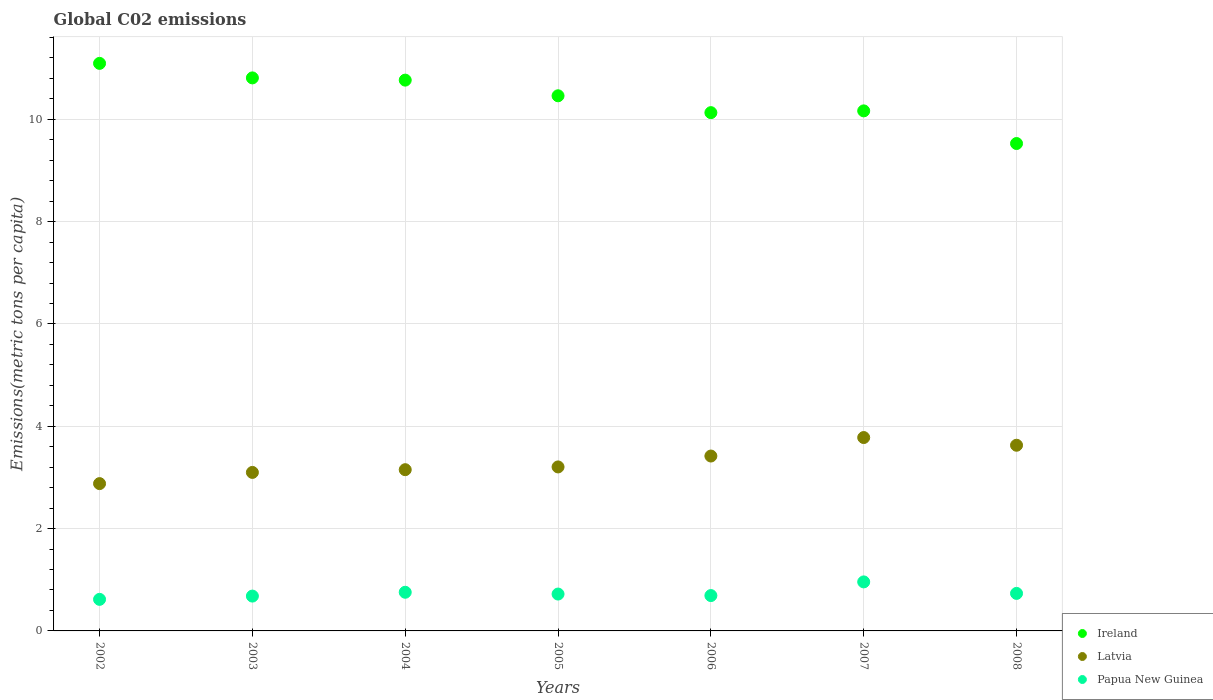How many different coloured dotlines are there?
Your answer should be compact. 3. What is the amount of CO2 emitted in in Ireland in 2002?
Your response must be concise. 11.09. Across all years, what is the maximum amount of CO2 emitted in in Papua New Guinea?
Keep it short and to the point. 0.96. Across all years, what is the minimum amount of CO2 emitted in in Papua New Guinea?
Your answer should be very brief. 0.62. What is the total amount of CO2 emitted in in Papua New Guinea in the graph?
Offer a terse response. 5.16. What is the difference between the amount of CO2 emitted in in Ireland in 2004 and that in 2008?
Keep it short and to the point. 1.24. What is the difference between the amount of CO2 emitted in in Papua New Guinea in 2003 and the amount of CO2 emitted in in Ireland in 2008?
Give a very brief answer. -8.85. What is the average amount of CO2 emitted in in Latvia per year?
Keep it short and to the point. 3.31. In the year 2006, what is the difference between the amount of CO2 emitted in in Latvia and amount of CO2 emitted in in Papua New Guinea?
Make the answer very short. 2.73. In how many years, is the amount of CO2 emitted in in Latvia greater than 10 metric tons per capita?
Keep it short and to the point. 0. What is the ratio of the amount of CO2 emitted in in Ireland in 2007 to that in 2008?
Give a very brief answer. 1.07. Is the amount of CO2 emitted in in Papua New Guinea in 2003 less than that in 2007?
Make the answer very short. Yes. What is the difference between the highest and the second highest amount of CO2 emitted in in Ireland?
Your answer should be compact. 0.28. What is the difference between the highest and the lowest amount of CO2 emitted in in Papua New Guinea?
Provide a succinct answer. 0.34. In how many years, is the amount of CO2 emitted in in Ireland greater than the average amount of CO2 emitted in in Ireland taken over all years?
Your answer should be compact. 4. Does the amount of CO2 emitted in in Latvia monotonically increase over the years?
Provide a succinct answer. No. Are the values on the major ticks of Y-axis written in scientific E-notation?
Keep it short and to the point. No. Does the graph contain any zero values?
Offer a terse response. No. Does the graph contain grids?
Your answer should be very brief. Yes. Where does the legend appear in the graph?
Your answer should be very brief. Bottom right. How many legend labels are there?
Make the answer very short. 3. What is the title of the graph?
Your answer should be very brief. Global C02 emissions. Does "Peru" appear as one of the legend labels in the graph?
Give a very brief answer. No. What is the label or title of the X-axis?
Your response must be concise. Years. What is the label or title of the Y-axis?
Offer a very short reply. Emissions(metric tons per capita). What is the Emissions(metric tons per capita) in Ireland in 2002?
Provide a succinct answer. 11.09. What is the Emissions(metric tons per capita) of Latvia in 2002?
Provide a succinct answer. 2.88. What is the Emissions(metric tons per capita) of Papua New Guinea in 2002?
Your answer should be very brief. 0.62. What is the Emissions(metric tons per capita) of Ireland in 2003?
Offer a terse response. 10.81. What is the Emissions(metric tons per capita) of Latvia in 2003?
Offer a terse response. 3.1. What is the Emissions(metric tons per capita) of Papua New Guinea in 2003?
Your answer should be very brief. 0.68. What is the Emissions(metric tons per capita) in Ireland in 2004?
Offer a very short reply. 10.77. What is the Emissions(metric tons per capita) of Latvia in 2004?
Provide a succinct answer. 3.15. What is the Emissions(metric tons per capita) of Papua New Guinea in 2004?
Offer a very short reply. 0.76. What is the Emissions(metric tons per capita) in Ireland in 2005?
Ensure brevity in your answer.  10.46. What is the Emissions(metric tons per capita) of Latvia in 2005?
Provide a short and direct response. 3.21. What is the Emissions(metric tons per capita) in Papua New Guinea in 2005?
Ensure brevity in your answer.  0.72. What is the Emissions(metric tons per capita) of Ireland in 2006?
Your response must be concise. 10.13. What is the Emissions(metric tons per capita) of Latvia in 2006?
Keep it short and to the point. 3.42. What is the Emissions(metric tons per capita) in Papua New Guinea in 2006?
Provide a short and direct response. 0.69. What is the Emissions(metric tons per capita) of Ireland in 2007?
Your answer should be very brief. 10.17. What is the Emissions(metric tons per capita) of Latvia in 2007?
Your response must be concise. 3.78. What is the Emissions(metric tons per capita) in Papua New Guinea in 2007?
Keep it short and to the point. 0.96. What is the Emissions(metric tons per capita) of Ireland in 2008?
Offer a very short reply. 9.53. What is the Emissions(metric tons per capita) of Latvia in 2008?
Make the answer very short. 3.63. What is the Emissions(metric tons per capita) of Papua New Guinea in 2008?
Offer a very short reply. 0.73. Across all years, what is the maximum Emissions(metric tons per capita) in Ireland?
Offer a very short reply. 11.09. Across all years, what is the maximum Emissions(metric tons per capita) in Latvia?
Offer a very short reply. 3.78. Across all years, what is the maximum Emissions(metric tons per capita) in Papua New Guinea?
Ensure brevity in your answer.  0.96. Across all years, what is the minimum Emissions(metric tons per capita) in Ireland?
Provide a succinct answer. 9.53. Across all years, what is the minimum Emissions(metric tons per capita) of Latvia?
Offer a very short reply. 2.88. Across all years, what is the minimum Emissions(metric tons per capita) in Papua New Guinea?
Give a very brief answer. 0.62. What is the total Emissions(metric tons per capita) of Ireland in the graph?
Offer a terse response. 72.95. What is the total Emissions(metric tons per capita) of Latvia in the graph?
Your response must be concise. 23.16. What is the total Emissions(metric tons per capita) of Papua New Guinea in the graph?
Keep it short and to the point. 5.16. What is the difference between the Emissions(metric tons per capita) in Ireland in 2002 and that in 2003?
Offer a very short reply. 0.28. What is the difference between the Emissions(metric tons per capita) of Latvia in 2002 and that in 2003?
Your answer should be compact. -0.22. What is the difference between the Emissions(metric tons per capita) in Papua New Guinea in 2002 and that in 2003?
Keep it short and to the point. -0.06. What is the difference between the Emissions(metric tons per capita) in Ireland in 2002 and that in 2004?
Offer a terse response. 0.33. What is the difference between the Emissions(metric tons per capita) in Latvia in 2002 and that in 2004?
Keep it short and to the point. -0.27. What is the difference between the Emissions(metric tons per capita) of Papua New Guinea in 2002 and that in 2004?
Give a very brief answer. -0.14. What is the difference between the Emissions(metric tons per capita) of Ireland in 2002 and that in 2005?
Give a very brief answer. 0.63. What is the difference between the Emissions(metric tons per capita) of Latvia in 2002 and that in 2005?
Provide a succinct answer. -0.33. What is the difference between the Emissions(metric tons per capita) in Papua New Guinea in 2002 and that in 2005?
Provide a short and direct response. -0.1. What is the difference between the Emissions(metric tons per capita) in Ireland in 2002 and that in 2006?
Give a very brief answer. 0.96. What is the difference between the Emissions(metric tons per capita) in Latvia in 2002 and that in 2006?
Ensure brevity in your answer.  -0.54. What is the difference between the Emissions(metric tons per capita) of Papua New Guinea in 2002 and that in 2006?
Your answer should be compact. -0.07. What is the difference between the Emissions(metric tons per capita) of Ireland in 2002 and that in 2007?
Give a very brief answer. 0.93. What is the difference between the Emissions(metric tons per capita) in Latvia in 2002 and that in 2007?
Provide a succinct answer. -0.9. What is the difference between the Emissions(metric tons per capita) in Papua New Guinea in 2002 and that in 2007?
Ensure brevity in your answer.  -0.34. What is the difference between the Emissions(metric tons per capita) in Ireland in 2002 and that in 2008?
Your answer should be very brief. 1.57. What is the difference between the Emissions(metric tons per capita) of Latvia in 2002 and that in 2008?
Make the answer very short. -0.75. What is the difference between the Emissions(metric tons per capita) in Papua New Guinea in 2002 and that in 2008?
Your answer should be very brief. -0.12. What is the difference between the Emissions(metric tons per capita) of Ireland in 2003 and that in 2004?
Ensure brevity in your answer.  0.04. What is the difference between the Emissions(metric tons per capita) in Latvia in 2003 and that in 2004?
Provide a short and direct response. -0.05. What is the difference between the Emissions(metric tons per capita) in Papua New Guinea in 2003 and that in 2004?
Your answer should be compact. -0.07. What is the difference between the Emissions(metric tons per capita) in Ireland in 2003 and that in 2005?
Offer a very short reply. 0.35. What is the difference between the Emissions(metric tons per capita) of Latvia in 2003 and that in 2005?
Offer a terse response. -0.11. What is the difference between the Emissions(metric tons per capita) in Papua New Guinea in 2003 and that in 2005?
Your response must be concise. -0.04. What is the difference between the Emissions(metric tons per capita) of Ireland in 2003 and that in 2006?
Your answer should be compact. 0.68. What is the difference between the Emissions(metric tons per capita) of Latvia in 2003 and that in 2006?
Offer a very short reply. -0.32. What is the difference between the Emissions(metric tons per capita) in Papua New Guinea in 2003 and that in 2006?
Give a very brief answer. -0.01. What is the difference between the Emissions(metric tons per capita) in Ireland in 2003 and that in 2007?
Make the answer very short. 0.64. What is the difference between the Emissions(metric tons per capita) in Latvia in 2003 and that in 2007?
Make the answer very short. -0.68. What is the difference between the Emissions(metric tons per capita) in Papua New Guinea in 2003 and that in 2007?
Provide a short and direct response. -0.28. What is the difference between the Emissions(metric tons per capita) in Ireland in 2003 and that in 2008?
Ensure brevity in your answer.  1.28. What is the difference between the Emissions(metric tons per capita) in Latvia in 2003 and that in 2008?
Provide a succinct answer. -0.53. What is the difference between the Emissions(metric tons per capita) in Papua New Guinea in 2003 and that in 2008?
Give a very brief answer. -0.05. What is the difference between the Emissions(metric tons per capita) in Ireland in 2004 and that in 2005?
Your response must be concise. 0.31. What is the difference between the Emissions(metric tons per capita) in Latvia in 2004 and that in 2005?
Make the answer very short. -0.05. What is the difference between the Emissions(metric tons per capita) of Papua New Guinea in 2004 and that in 2005?
Keep it short and to the point. 0.04. What is the difference between the Emissions(metric tons per capita) in Ireland in 2004 and that in 2006?
Ensure brevity in your answer.  0.64. What is the difference between the Emissions(metric tons per capita) in Latvia in 2004 and that in 2006?
Your answer should be very brief. -0.27. What is the difference between the Emissions(metric tons per capita) of Papua New Guinea in 2004 and that in 2006?
Keep it short and to the point. 0.06. What is the difference between the Emissions(metric tons per capita) in Ireland in 2004 and that in 2007?
Offer a very short reply. 0.6. What is the difference between the Emissions(metric tons per capita) in Latvia in 2004 and that in 2007?
Your response must be concise. -0.63. What is the difference between the Emissions(metric tons per capita) of Papua New Guinea in 2004 and that in 2007?
Offer a very short reply. -0.2. What is the difference between the Emissions(metric tons per capita) in Ireland in 2004 and that in 2008?
Provide a succinct answer. 1.24. What is the difference between the Emissions(metric tons per capita) in Latvia in 2004 and that in 2008?
Ensure brevity in your answer.  -0.48. What is the difference between the Emissions(metric tons per capita) in Papua New Guinea in 2004 and that in 2008?
Provide a short and direct response. 0.02. What is the difference between the Emissions(metric tons per capita) in Ireland in 2005 and that in 2006?
Your response must be concise. 0.33. What is the difference between the Emissions(metric tons per capita) of Latvia in 2005 and that in 2006?
Give a very brief answer. -0.21. What is the difference between the Emissions(metric tons per capita) in Papua New Guinea in 2005 and that in 2006?
Provide a succinct answer. 0.03. What is the difference between the Emissions(metric tons per capita) in Ireland in 2005 and that in 2007?
Provide a short and direct response. 0.29. What is the difference between the Emissions(metric tons per capita) of Latvia in 2005 and that in 2007?
Provide a short and direct response. -0.57. What is the difference between the Emissions(metric tons per capita) in Papua New Guinea in 2005 and that in 2007?
Your response must be concise. -0.24. What is the difference between the Emissions(metric tons per capita) of Ireland in 2005 and that in 2008?
Keep it short and to the point. 0.93. What is the difference between the Emissions(metric tons per capita) in Latvia in 2005 and that in 2008?
Offer a very short reply. -0.42. What is the difference between the Emissions(metric tons per capita) of Papua New Guinea in 2005 and that in 2008?
Your answer should be very brief. -0.01. What is the difference between the Emissions(metric tons per capita) in Ireland in 2006 and that in 2007?
Offer a very short reply. -0.03. What is the difference between the Emissions(metric tons per capita) in Latvia in 2006 and that in 2007?
Ensure brevity in your answer.  -0.36. What is the difference between the Emissions(metric tons per capita) in Papua New Guinea in 2006 and that in 2007?
Ensure brevity in your answer.  -0.27. What is the difference between the Emissions(metric tons per capita) of Ireland in 2006 and that in 2008?
Provide a short and direct response. 0.6. What is the difference between the Emissions(metric tons per capita) of Latvia in 2006 and that in 2008?
Ensure brevity in your answer.  -0.21. What is the difference between the Emissions(metric tons per capita) of Papua New Guinea in 2006 and that in 2008?
Offer a terse response. -0.04. What is the difference between the Emissions(metric tons per capita) in Ireland in 2007 and that in 2008?
Your answer should be very brief. 0.64. What is the difference between the Emissions(metric tons per capita) of Latvia in 2007 and that in 2008?
Provide a short and direct response. 0.15. What is the difference between the Emissions(metric tons per capita) in Papua New Guinea in 2007 and that in 2008?
Provide a succinct answer. 0.22. What is the difference between the Emissions(metric tons per capita) in Ireland in 2002 and the Emissions(metric tons per capita) in Latvia in 2003?
Your answer should be compact. 8. What is the difference between the Emissions(metric tons per capita) of Ireland in 2002 and the Emissions(metric tons per capita) of Papua New Guinea in 2003?
Your answer should be compact. 10.41. What is the difference between the Emissions(metric tons per capita) in Latvia in 2002 and the Emissions(metric tons per capita) in Papua New Guinea in 2003?
Give a very brief answer. 2.2. What is the difference between the Emissions(metric tons per capita) of Ireland in 2002 and the Emissions(metric tons per capita) of Latvia in 2004?
Your answer should be very brief. 7.94. What is the difference between the Emissions(metric tons per capita) in Ireland in 2002 and the Emissions(metric tons per capita) in Papua New Guinea in 2004?
Ensure brevity in your answer.  10.34. What is the difference between the Emissions(metric tons per capita) of Latvia in 2002 and the Emissions(metric tons per capita) of Papua New Guinea in 2004?
Your response must be concise. 2.12. What is the difference between the Emissions(metric tons per capita) of Ireland in 2002 and the Emissions(metric tons per capita) of Latvia in 2005?
Give a very brief answer. 7.89. What is the difference between the Emissions(metric tons per capita) of Ireland in 2002 and the Emissions(metric tons per capita) of Papua New Guinea in 2005?
Keep it short and to the point. 10.37. What is the difference between the Emissions(metric tons per capita) in Latvia in 2002 and the Emissions(metric tons per capita) in Papua New Guinea in 2005?
Your answer should be very brief. 2.16. What is the difference between the Emissions(metric tons per capita) in Ireland in 2002 and the Emissions(metric tons per capita) in Latvia in 2006?
Make the answer very short. 7.67. What is the difference between the Emissions(metric tons per capita) in Ireland in 2002 and the Emissions(metric tons per capita) in Papua New Guinea in 2006?
Provide a succinct answer. 10.4. What is the difference between the Emissions(metric tons per capita) of Latvia in 2002 and the Emissions(metric tons per capita) of Papua New Guinea in 2006?
Provide a succinct answer. 2.19. What is the difference between the Emissions(metric tons per capita) in Ireland in 2002 and the Emissions(metric tons per capita) in Latvia in 2007?
Keep it short and to the point. 7.31. What is the difference between the Emissions(metric tons per capita) in Ireland in 2002 and the Emissions(metric tons per capita) in Papua New Guinea in 2007?
Give a very brief answer. 10.14. What is the difference between the Emissions(metric tons per capita) of Latvia in 2002 and the Emissions(metric tons per capita) of Papua New Guinea in 2007?
Offer a very short reply. 1.92. What is the difference between the Emissions(metric tons per capita) in Ireland in 2002 and the Emissions(metric tons per capita) in Latvia in 2008?
Ensure brevity in your answer.  7.46. What is the difference between the Emissions(metric tons per capita) of Ireland in 2002 and the Emissions(metric tons per capita) of Papua New Guinea in 2008?
Provide a short and direct response. 10.36. What is the difference between the Emissions(metric tons per capita) in Latvia in 2002 and the Emissions(metric tons per capita) in Papua New Guinea in 2008?
Provide a succinct answer. 2.15. What is the difference between the Emissions(metric tons per capita) of Ireland in 2003 and the Emissions(metric tons per capita) of Latvia in 2004?
Provide a short and direct response. 7.66. What is the difference between the Emissions(metric tons per capita) in Ireland in 2003 and the Emissions(metric tons per capita) in Papua New Guinea in 2004?
Your answer should be very brief. 10.05. What is the difference between the Emissions(metric tons per capita) in Latvia in 2003 and the Emissions(metric tons per capita) in Papua New Guinea in 2004?
Your answer should be compact. 2.34. What is the difference between the Emissions(metric tons per capita) of Ireland in 2003 and the Emissions(metric tons per capita) of Latvia in 2005?
Provide a succinct answer. 7.6. What is the difference between the Emissions(metric tons per capita) of Ireland in 2003 and the Emissions(metric tons per capita) of Papua New Guinea in 2005?
Make the answer very short. 10.09. What is the difference between the Emissions(metric tons per capita) of Latvia in 2003 and the Emissions(metric tons per capita) of Papua New Guinea in 2005?
Your answer should be very brief. 2.38. What is the difference between the Emissions(metric tons per capita) in Ireland in 2003 and the Emissions(metric tons per capita) in Latvia in 2006?
Ensure brevity in your answer.  7.39. What is the difference between the Emissions(metric tons per capita) in Ireland in 2003 and the Emissions(metric tons per capita) in Papua New Guinea in 2006?
Give a very brief answer. 10.12. What is the difference between the Emissions(metric tons per capita) in Latvia in 2003 and the Emissions(metric tons per capita) in Papua New Guinea in 2006?
Give a very brief answer. 2.41. What is the difference between the Emissions(metric tons per capita) in Ireland in 2003 and the Emissions(metric tons per capita) in Latvia in 2007?
Your answer should be very brief. 7.03. What is the difference between the Emissions(metric tons per capita) of Ireland in 2003 and the Emissions(metric tons per capita) of Papua New Guinea in 2007?
Give a very brief answer. 9.85. What is the difference between the Emissions(metric tons per capita) in Latvia in 2003 and the Emissions(metric tons per capita) in Papua New Guinea in 2007?
Provide a short and direct response. 2.14. What is the difference between the Emissions(metric tons per capita) in Ireland in 2003 and the Emissions(metric tons per capita) in Latvia in 2008?
Ensure brevity in your answer.  7.18. What is the difference between the Emissions(metric tons per capita) in Ireland in 2003 and the Emissions(metric tons per capita) in Papua New Guinea in 2008?
Your response must be concise. 10.08. What is the difference between the Emissions(metric tons per capita) of Latvia in 2003 and the Emissions(metric tons per capita) of Papua New Guinea in 2008?
Provide a succinct answer. 2.36. What is the difference between the Emissions(metric tons per capita) in Ireland in 2004 and the Emissions(metric tons per capita) in Latvia in 2005?
Your answer should be compact. 7.56. What is the difference between the Emissions(metric tons per capita) of Ireland in 2004 and the Emissions(metric tons per capita) of Papua New Guinea in 2005?
Ensure brevity in your answer.  10.05. What is the difference between the Emissions(metric tons per capita) of Latvia in 2004 and the Emissions(metric tons per capita) of Papua New Guinea in 2005?
Make the answer very short. 2.43. What is the difference between the Emissions(metric tons per capita) of Ireland in 2004 and the Emissions(metric tons per capita) of Latvia in 2006?
Your answer should be very brief. 7.35. What is the difference between the Emissions(metric tons per capita) in Ireland in 2004 and the Emissions(metric tons per capita) in Papua New Guinea in 2006?
Provide a succinct answer. 10.08. What is the difference between the Emissions(metric tons per capita) in Latvia in 2004 and the Emissions(metric tons per capita) in Papua New Guinea in 2006?
Make the answer very short. 2.46. What is the difference between the Emissions(metric tons per capita) of Ireland in 2004 and the Emissions(metric tons per capita) of Latvia in 2007?
Your response must be concise. 6.99. What is the difference between the Emissions(metric tons per capita) in Ireland in 2004 and the Emissions(metric tons per capita) in Papua New Guinea in 2007?
Offer a terse response. 9.81. What is the difference between the Emissions(metric tons per capita) in Latvia in 2004 and the Emissions(metric tons per capita) in Papua New Guinea in 2007?
Ensure brevity in your answer.  2.19. What is the difference between the Emissions(metric tons per capita) in Ireland in 2004 and the Emissions(metric tons per capita) in Latvia in 2008?
Make the answer very short. 7.14. What is the difference between the Emissions(metric tons per capita) of Ireland in 2004 and the Emissions(metric tons per capita) of Papua New Guinea in 2008?
Offer a terse response. 10.03. What is the difference between the Emissions(metric tons per capita) of Latvia in 2004 and the Emissions(metric tons per capita) of Papua New Guinea in 2008?
Ensure brevity in your answer.  2.42. What is the difference between the Emissions(metric tons per capita) of Ireland in 2005 and the Emissions(metric tons per capita) of Latvia in 2006?
Provide a short and direct response. 7.04. What is the difference between the Emissions(metric tons per capita) in Ireland in 2005 and the Emissions(metric tons per capita) in Papua New Guinea in 2006?
Make the answer very short. 9.77. What is the difference between the Emissions(metric tons per capita) of Latvia in 2005 and the Emissions(metric tons per capita) of Papua New Guinea in 2006?
Provide a succinct answer. 2.51. What is the difference between the Emissions(metric tons per capita) of Ireland in 2005 and the Emissions(metric tons per capita) of Latvia in 2007?
Give a very brief answer. 6.68. What is the difference between the Emissions(metric tons per capita) in Ireland in 2005 and the Emissions(metric tons per capita) in Papua New Guinea in 2007?
Give a very brief answer. 9.5. What is the difference between the Emissions(metric tons per capita) of Latvia in 2005 and the Emissions(metric tons per capita) of Papua New Guinea in 2007?
Ensure brevity in your answer.  2.25. What is the difference between the Emissions(metric tons per capita) in Ireland in 2005 and the Emissions(metric tons per capita) in Latvia in 2008?
Give a very brief answer. 6.83. What is the difference between the Emissions(metric tons per capita) in Ireland in 2005 and the Emissions(metric tons per capita) in Papua New Guinea in 2008?
Keep it short and to the point. 9.73. What is the difference between the Emissions(metric tons per capita) in Latvia in 2005 and the Emissions(metric tons per capita) in Papua New Guinea in 2008?
Ensure brevity in your answer.  2.47. What is the difference between the Emissions(metric tons per capita) of Ireland in 2006 and the Emissions(metric tons per capita) of Latvia in 2007?
Ensure brevity in your answer.  6.35. What is the difference between the Emissions(metric tons per capita) in Ireland in 2006 and the Emissions(metric tons per capita) in Papua New Guinea in 2007?
Your answer should be compact. 9.17. What is the difference between the Emissions(metric tons per capita) of Latvia in 2006 and the Emissions(metric tons per capita) of Papua New Guinea in 2007?
Keep it short and to the point. 2.46. What is the difference between the Emissions(metric tons per capita) in Ireland in 2006 and the Emissions(metric tons per capita) in Latvia in 2008?
Offer a terse response. 6.5. What is the difference between the Emissions(metric tons per capita) of Ireland in 2006 and the Emissions(metric tons per capita) of Papua New Guinea in 2008?
Your response must be concise. 9.4. What is the difference between the Emissions(metric tons per capita) of Latvia in 2006 and the Emissions(metric tons per capita) of Papua New Guinea in 2008?
Ensure brevity in your answer.  2.69. What is the difference between the Emissions(metric tons per capita) in Ireland in 2007 and the Emissions(metric tons per capita) in Latvia in 2008?
Keep it short and to the point. 6.54. What is the difference between the Emissions(metric tons per capita) in Ireland in 2007 and the Emissions(metric tons per capita) in Papua New Guinea in 2008?
Give a very brief answer. 9.43. What is the difference between the Emissions(metric tons per capita) in Latvia in 2007 and the Emissions(metric tons per capita) in Papua New Guinea in 2008?
Give a very brief answer. 3.05. What is the average Emissions(metric tons per capita) in Ireland per year?
Offer a very short reply. 10.42. What is the average Emissions(metric tons per capita) of Latvia per year?
Offer a terse response. 3.31. What is the average Emissions(metric tons per capita) of Papua New Guinea per year?
Offer a terse response. 0.74. In the year 2002, what is the difference between the Emissions(metric tons per capita) in Ireland and Emissions(metric tons per capita) in Latvia?
Make the answer very short. 8.21. In the year 2002, what is the difference between the Emissions(metric tons per capita) of Ireland and Emissions(metric tons per capita) of Papua New Guinea?
Provide a succinct answer. 10.48. In the year 2002, what is the difference between the Emissions(metric tons per capita) in Latvia and Emissions(metric tons per capita) in Papua New Guinea?
Your response must be concise. 2.26. In the year 2003, what is the difference between the Emissions(metric tons per capita) in Ireland and Emissions(metric tons per capita) in Latvia?
Give a very brief answer. 7.71. In the year 2003, what is the difference between the Emissions(metric tons per capita) of Ireland and Emissions(metric tons per capita) of Papua New Guinea?
Offer a terse response. 10.13. In the year 2003, what is the difference between the Emissions(metric tons per capita) in Latvia and Emissions(metric tons per capita) in Papua New Guinea?
Make the answer very short. 2.42. In the year 2004, what is the difference between the Emissions(metric tons per capita) of Ireland and Emissions(metric tons per capita) of Latvia?
Your response must be concise. 7.61. In the year 2004, what is the difference between the Emissions(metric tons per capita) in Ireland and Emissions(metric tons per capita) in Papua New Guinea?
Make the answer very short. 10.01. In the year 2004, what is the difference between the Emissions(metric tons per capita) of Latvia and Emissions(metric tons per capita) of Papua New Guinea?
Ensure brevity in your answer.  2.4. In the year 2005, what is the difference between the Emissions(metric tons per capita) of Ireland and Emissions(metric tons per capita) of Latvia?
Provide a short and direct response. 7.25. In the year 2005, what is the difference between the Emissions(metric tons per capita) in Ireland and Emissions(metric tons per capita) in Papua New Guinea?
Your answer should be very brief. 9.74. In the year 2005, what is the difference between the Emissions(metric tons per capita) of Latvia and Emissions(metric tons per capita) of Papua New Guinea?
Ensure brevity in your answer.  2.48. In the year 2006, what is the difference between the Emissions(metric tons per capita) in Ireland and Emissions(metric tons per capita) in Latvia?
Give a very brief answer. 6.71. In the year 2006, what is the difference between the Emissions(metric tons per capita) of Ireland and Emissions(metric tons per capita) of Papua New Guinea?
Ensure brevity in your answer.  9.44. In the year 2006, what is the difference between the Emissions(metric tons per capita) in Latvia and Emissions(metric tons per capita) in Papua New Guinea?
Keep it short and to the point. 2.73. In the year 2007, what is the difference between the Emissions(metric tons per capita) in Ireland and Emissions(metric tons per capita) in Latvia?
Your answer should be very brief. 6.39. In the year 2007, what is the difference between the Emissions(metric tons per capita) of Ireland and Emissions(metric tons per capita) of Papua New Guinea?
Your response must be concise. 9.21. In the year 2007, what is the difference between the Emissions(metric tons per capita) of Latvia and Emissions(metric tons per capita) of Papua New Guinea?
Give a very brief answer. 2.82. In the year 2008, what is the difference between the Emissions(metric tons per capita) of Ireland and Emissions(metric tons per capita) of Latvia?
Your answer should be compact. 5.9. In the year 2008, what is the difference between the Emissions(metric tons per capita) of Ireland and Emissions(metric tons per capita) of Papua New Guinea?
Make the answer very short. 8.79. In the year 2008, what is the difference between the Emissions(metric tons per capita) of Latvia and Emissions(metric tons per capita) of Papua New Guinea?
Keep it short and to the point. 2.9. What is the ratio of the Emissions(metric tons per capita) of Ireland in 2002 to that in 2003?
Your answer should be compact. 1.03. What is the ratio of the Emissions(metric tons per capita) in Latvia in 2002 to that in 2003?
Ensure brevity in your answer.  0.93. What is the ratio of the Emissions(metric tons per capita) of Papua New Guinea in 2002 to that in 2003?
Offer a very short reply. 0.91. What is the ratio of the Emissions(metric tons per capita) in Ireland in 2002 to that in 2004?
Offer a terse response. 1.03. What is the ratio of the Emissions(metric tons per capita) in Latvia in 2002 to that in 2004?
Ensure brevity in your answer.  0.91. What is the ratio of the Emissions(metric tons per capita) in Papua New Guinea in 2002 to that in 2004?
Give a very brief answer. 0.82. What is the ratio of the Emissions(metric tons per capita) in Ireland in 2002 to that in 2005?
Provide a succinct answer. 1.06. What is the ratio of the Emissions(metric tons per capita) in Latvia in 2002 to that in 2005?
Give a very brief answer. 0.9. What is the ratio of the Emissions(metric tons per capita) of Papua New Guinea in 2002 to that in 2005?
Give a very brief answer. 0.86. What is the ratio of the Emissions(metric tons per capita) of Ireland in 2002 to that in 2006?
Ensure brevity in your answer.  1.1. What is the ratio of the Emissions(metric tons per capita) of Latvia in 2002 to that in 2006?
Give a very brief answer. 0.84. What is the ratio of the Emissions(metric tons per capita) of Papua New Guinea in 2002 to that in 2006?
Ensure brevity in your answer.  0.89. What is the ratio of the Emissions(metric tons per capita) in Ireland in 2002 to that in 2007?
Ensure brevity in your answer.  1.09. What is the ratio of the Emissions(metric tons per capita) in Latvia in 2002 to that in 2007?
Your answer should be compact. 0.76. What is the ratio of the Emissions(metric tons per capita) of Papua New Guinea in 2002 to that in 2007?
Keep it short and to the point. 0.64. What is the ratio of the Emissions(metric tons per capita) of Ireland in 2002 to that in 2008?
Keep it short and to the point. 1.16. What is the ratio of the Emissions(metric tons per capita) in Latvia in 2002 to that in 2008?
Ensure brevity in your answer.  0.79. What is the ratio of the Emissions(metric tons per capita) in Papua New Guinea in 2002 to that in 2008?
Ensure brevity in your answer.  0.84. What is the ratio of the Emissions(metric tons per capita) in Latvia in 2003 to that in 2004?
Provide a succinct answer. 0.98. What is the ratio of the Emissions(metric tons per capita) in Papua New Guinea in 2003 to that in 2004?
Provide a succinct answer. 0.9. What is the ratio of the Emissions(metric tons per capita) in Ireland in 2003 to that in 2005?
Offer a very short reply. 1.03. What is the ratio of the Emissions(metric tons per capita) in Latvia in 2003 to that in 2005?
Provide a succinct answer. 0.97. What is the ratio of the Emissions(metric tons per capita) in Papua New Guinea in 2003 to that in 2005?
Keep it short and to the point. 0.94. What is the ratio of the Emissions(metric tons per capita) of Ireland in 2003 to that in 2006?
Ensure brevity in your answer.  1.07. What is the ratio of the Emissions(metric tons per capita) of Latvia in 2003 to that in 2006?
Keep it short and to the point. 0.91. What is the ratio of the Emissions(metric tons per capita) of Papua New Guinea in 2003 to that in 2006?
Ensure brevity in your answer.  0.99. What is the ratio of the Emissions(metric tons per capita) of Ireland in 2003 to that in 2007?
Offer a terse response. 1.06. What is the ratio of the Emissions(metric tons per capita) of Latvia in 2003 to that in 2007?
Your response must be concise. 0.82. What is the ratio of the Emissions(metric tons per capita) in Papua New Guinea in 2003 to that in 2007?
Provide a succinct answer. 0.71. What is the ratio of the Emissions(metric tons per capita) of Ireland in 2003 to that in 2008?
Your answer should be compact. 1.13. What is the ratio of the Emissions(metric tons per capita) of Latvia in 2003 to that in 2008?
Make the answer very short. 0.85. What is the ratio of the Emissions(metric tons per capita) of Papua New Guinea in 2003 to that in 2008?
Ensure brevity in your answer.  0.93. What is the ratio of the Emissions(metric tons per capita) in Ireland in 2004 to that in 2005?
Offer a terse response. 1.03. What is the ratio of the Emissions(metric tons per capita) of Latvia in 2004 to that in 2005?
Keep it short and to the point. 0.98. What is the ratio of the Emissions(metric tons per capita) of Papua New Guinea in 2004 to that in 2005?
Ensure brevity in your answer.  1.05. What is the ratio of the Emissions(metric tons per capita) of Ireland in 2004 to that in 2006?
Offer a very short reply. 1.06. What is the ratio of the Emissions(metric tons per capita) of Latvia in 2004 to that in 2006?
Your answer should be very brief. 0.92. What is the ratio of the Emissions(metric tons per capita) of Papua New Guinea in 2004 to that in 2006?
Make the answer very short. 1.09. What is the ratio of the Emissions(metric tons per capita) of Ireland in 2004 to that in 2007?
Provide a succinct answer. 1.06. What is the ratio of the Emissions(metric tons per capita) in Latvia in 2004 to that in 2007?
Ensure brevity in your answer.  0.83. What is the ratio of the Emissions(metric tons per capita) in Papua New Guinea in 2004 to that in 2007?
Make the answer very short. 0.79. What is the ratio of the Emissions(metric tons per capita) of Ireland in 2004 to that in 2008?
Offer a very short reply. 1.13. What is the ratio of the Emissions(metric tons per capita) of Latvia in 2004 to that in 2008?
Offer a terse response. 0.87. What is the ratio of the Emissions(metric tons per capita) in Papua New Guinea in 2004 to that in 2008?
Keep it short and to the point. 1.03. What is the ratio of the Emissions(metric tons per capita) in Ireland in 2005 to that in 2006?
Offer a very short reply. 1.03. What is the ratio of the Emissions(metric tons per capita) of Latvia in 2005 to that in 2006?
Your answer should be compact. 0.94. What is the ratio of the Emissions(metric tons per capita) in Papua New Guinea in 2005 to that in 2006?
Provide a succinct answer. 1.04. What is the ratio of the Emissions(metric tons per capita) of Ireland in 2005 to that in 2007?
Your response must be concise. 1.03. What is the ratio of the Emissions(metric tons per capita) in Latvia in 2005 to that in 2007?
Provide a short and direct response. 0.85. What is the ratio of the Emissions(metric tons per capita) of Papua New Guinea in 2005 to that in 2007?
Your answer should be very brief. 0.75. What is the ratio of the Emissions(metric tons per capita) of Ireland in 2005 to that in 2008?
Ensure brevity in your answer.  1.1. What is the ratio of the Emissions(metric tons per capita) of Latvia in 2005 to that in 2008?
Your response must be concise. 0.88. What is the ratio of the Emissions(metric tons per capita) in Papua New Guinea in 2005 to that in 2008?
Offer a very short reply. 0.98. What is the ratio of the Emissions(metric tons per capita) of Latvia in 2006 to that in 2007?
Make the answer very short. 0.9. What is the ratio of the Emissions(metric tons per capita) in Papua New Guinea in 2006 to that in 2007?
Your response must be concise. 0.72. What is the ratio of the Emissions(metric tons per capita) of Ireland in 2006 to that in 2008?
Give a very brief answer. 1.06. What is the ratio of the Emissions(metric tons per capita) of Latvia in 2006 to that in 2008?
Provide a short and direct response. 0.94. What is the ratio of the Emissions(metric tons per capita) of Papua New Guinea in 2006 to that in 2008?
Provide a succinct answer. 0.94. What is the ratio of the Emissions(metric tons per capita) in Ireland in 2007 to that in 2008?
Your answer should be very brief. 1.07. What is the ratio of the Emissions(metric tons per capita) of Latvia in 2007 to that in 2008?
Provide a short and direct response. 1.04. What is the ratio of the Emissions(metric tons per capita) of Papua New Guinea in 2007 to that in 2008?
Offer a very short reply. 1.31. What is the difference between the highest and the second highest Emissions(metric tons per capita) in Ireland?
Your answer should be very brief. 0.28. What is the difference between the highest and the second highest Emissions(metric tons per capita) of Latvia?
Provide a short and direct response. 0.15. What is the difference between the highest and the second highest Emissions(metric tons per capita) in Papua New Guinea?
Provide a succinct answer. 0.2. What is the difference between the highest and the lowest Emissions(metric tons per capita) of Ireland?
Ensure brevity in your answer.  1.57. What is the difference between the highest and the lowest Emissions(metric tons per capita) of Latvia?
Provide a short and direct response. 0.9. What is the difference between the highest and the lowest Emissions(metric tons per capita) in Papua New Guinea?
Give a very brief answer. 0.34. 